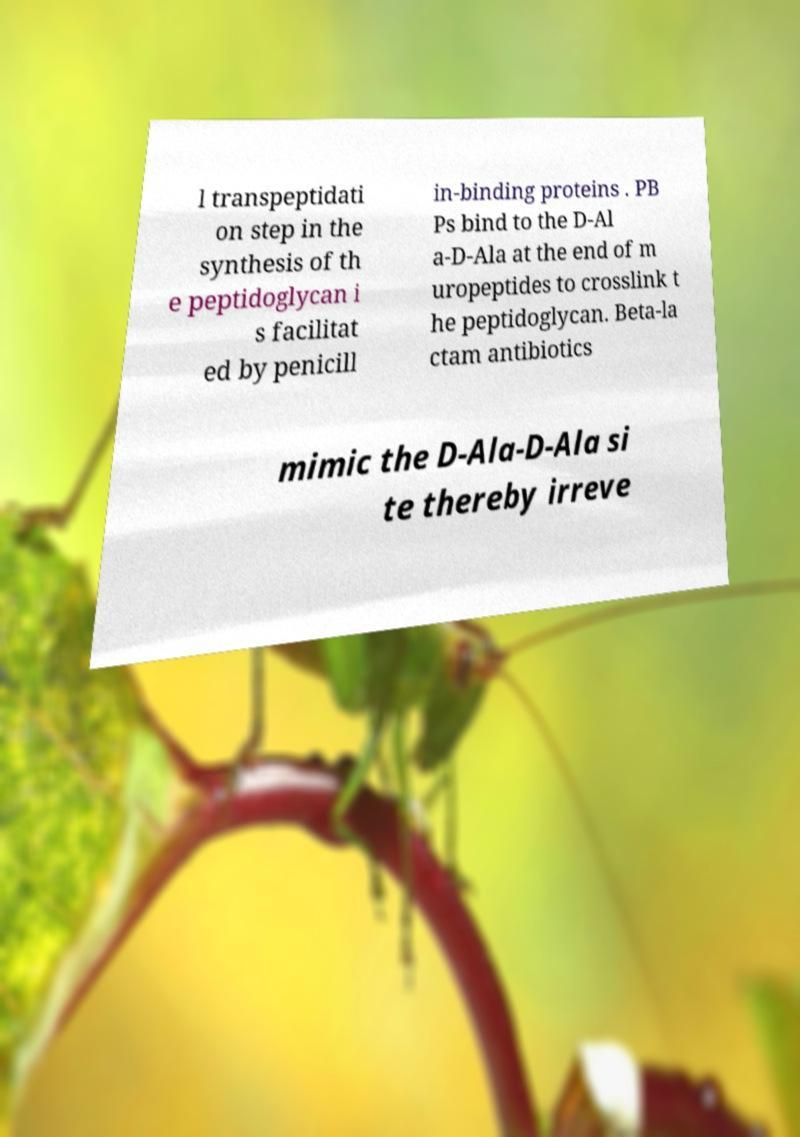What messages or text are displayed in this image? I need them in a readable, typed format. l transpeptidati on step in the synthesis of th e peptidoglycan i s facilitat ed by penicill in-binding proteins . PB Ps bind to the D-Al a-D-Ala at the end of m uropeptides to crosslink t he peptidoglycan. Beta-la ctam antibiotics mimic the D-Ala-D-Ala si te thereby irreve 